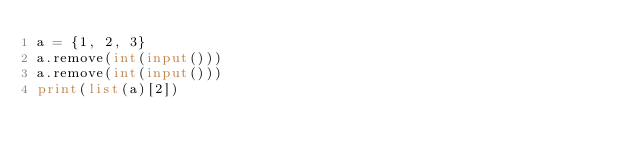<code> <loc_0><loc_0><loc_500><loc_500><_Python_>a = {1, 2, 3}
a.remove(int(input()))
a.remove(int(input()))
print(list(a)[2])</code> 